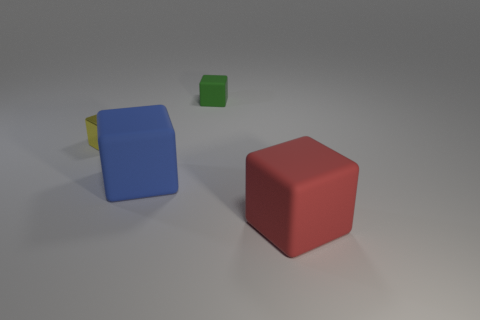What color is the other tiny matte thing that is the same shape as the red rubber thing?
Offer a very short reply. Green. Is the blue matte object the same shape as the green matte thing?
Provide a short and direct response. Yes. Are there any blue rubber things that have the same shape as the green object?
Keep it short and to the point. Yes. What is the material of the cube that is right of the tiny object that is right of the large cube that is on the left side of the red thing?
Make the answer very short. Rubber. Do the green matte object and the metallic cube have the same size?
Make the answer very short. Yes. What material is the red block?
Give a very brief answer. Rubber. Is the shape of the thing behind the yellow metal cube the same as  the metallic object?
Make the answer very short. Yes. How many things are either large green cylinders or big blue matte cubes?
Your answer should be compact. 1. Are the big object that is behind the big red rubber thing and the tiny yellow block made of the same material?
Your answer should be very brief. No. What is the size of the red rubber cube?
Make the answer very short. Large. 